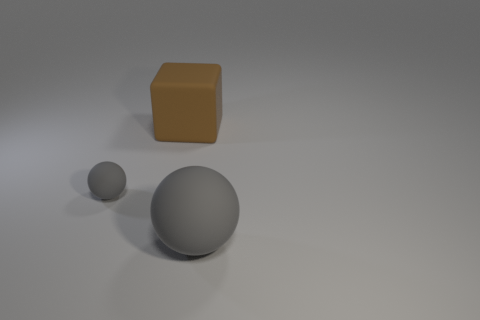Subtract 1 blocks. How many blocks are left? 0 Add 1 rubber spheres. How many objects exist? 4 Subtract all red spheres. Subtract all cyan cubes. How many spheres are left? 2 Subtract all big red blocks. Subtract all brown rubber blocks. How many objects are left? 2 Add 3 small balls. How many small balls are left? 4 Add 3 big brown rubber cubes. How many big brown rubber cubes exist? 4 Subtract 0 green blocks. How many objects are left? 3 Subtract all balls. How many objects are left? 1 